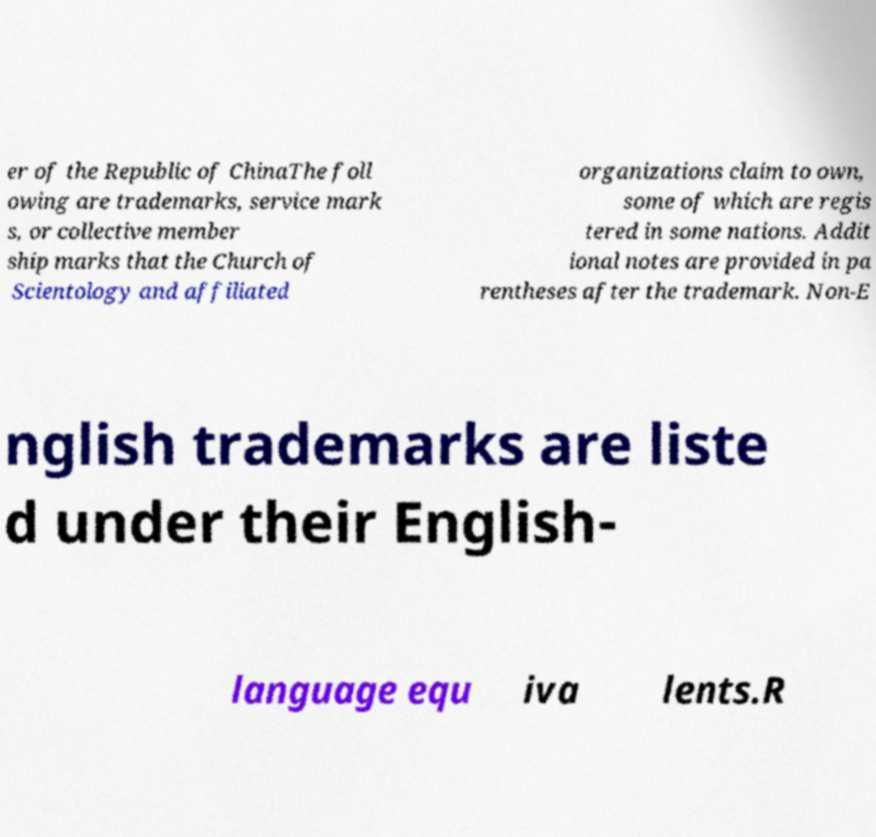Could you assist in decoding the text presented in this image and type it out clearly? er of the Republic of ChinaThe foll owing are trademarks, service mark s, or collective member ship marks that the Church of Scientology and affiliated organizations claim to own, some of which are regis tered in some nations. Addit ional notes are provided in pa rentheses after the trademark. Non-E nglish trademarks are liste d under their English- language equ iva lents.R 